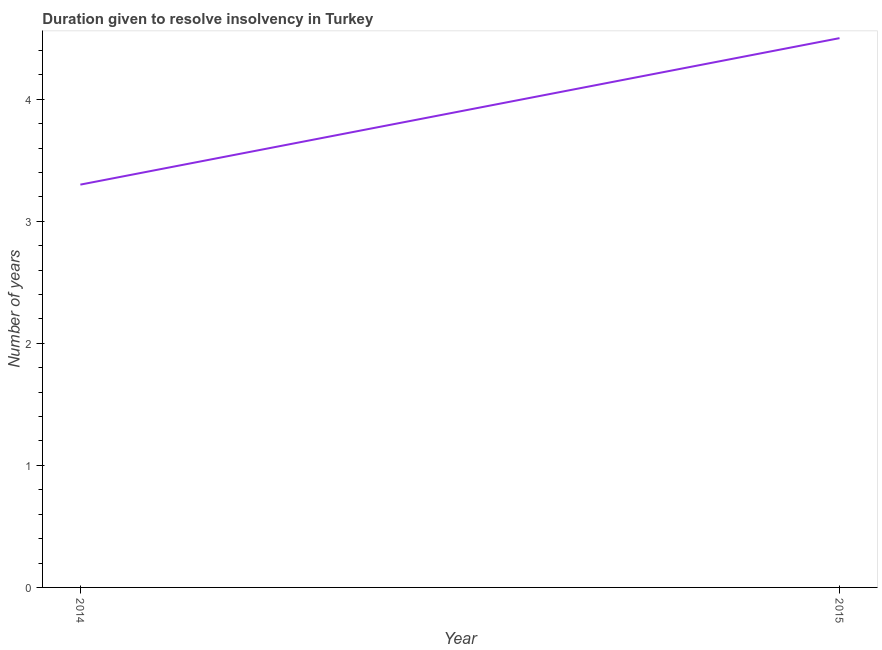Across all years, what is the minimum number of years to resolve insolvency?
Your answer should be very brief. 3.3. In which year was the number of years to resolve insolvency maximum?
Provide a succinct answer. 2015. What is the difference between the number of years to resolve insolvency in 2014 and 2015?
Ensure brevity in your answer.  -1.2. What is the average number of years to resolve insolvency per year?
Provide a short and direct response. 3.9. What is the median number of years to resolve insolvency?
Offer a terse response. 3.9. In how many years, is the number of years to resolve insolvency greater than 2.6 ?
Ensure brevity in your answer.  2. What is the ratio of the number of years to resolve insolvency in 2014 to that in 2015?
Ensure brevity in your answer.  0.73. Is the number of years to resolve insolvency in 2014 less than that in 2015?
Give a very brief answer. Yes. How many lines are there?
Give a very brief answer. 1. How many years are there in the graph?
Offer a very short reply. 2. Are the values on the major ticks of Y-axis written in scientific E-notation?
Your answer should be compact. No. Does the graph contain any zero values?
Your response must be concise. No. What is the title of the graph?
Make the answer very short. Duration given to resolve insolvency in Turkey. What is the label or title of the Y-axis?
Your response must be concise. Number of years. What is the Number of years in 2014?
Your answer should be compact. 3.3. What is the Number of years of 2015?
Provide a short and direct response. 4.5. What is the difference between the Number of years in 2014 and 2015?
Your response must be concise. -1.2. What is the ratio of the Number of years in 2014 to that in 2015?
Your answer should be very brief. 0.73. 